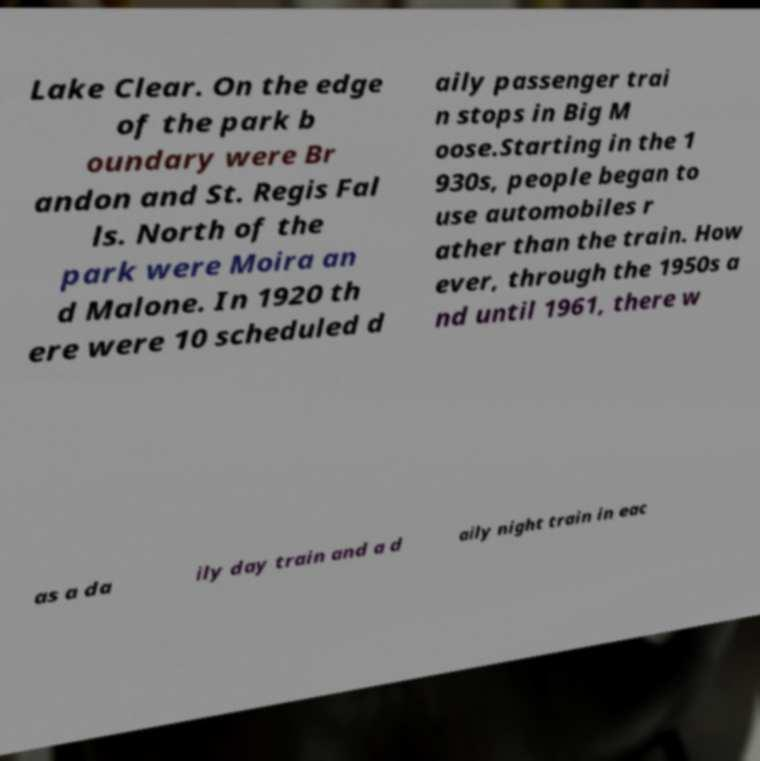What messages or text are displayed in this image? I need them in a readable, typed format. Lake Clear. On the edge of the park b oundary were Br andon and St. Regis Fal ls. North of the park were Moira an d Malone. In 1920 th ere were 10 scheduled d aily passenger trai n stops in Big M oose.Starting in the 1 930s, people began to use automobiles r ather than the train. How ever, through the 1950s a nd until 1961, there w as a da ily day train and a d aily night train in eac 